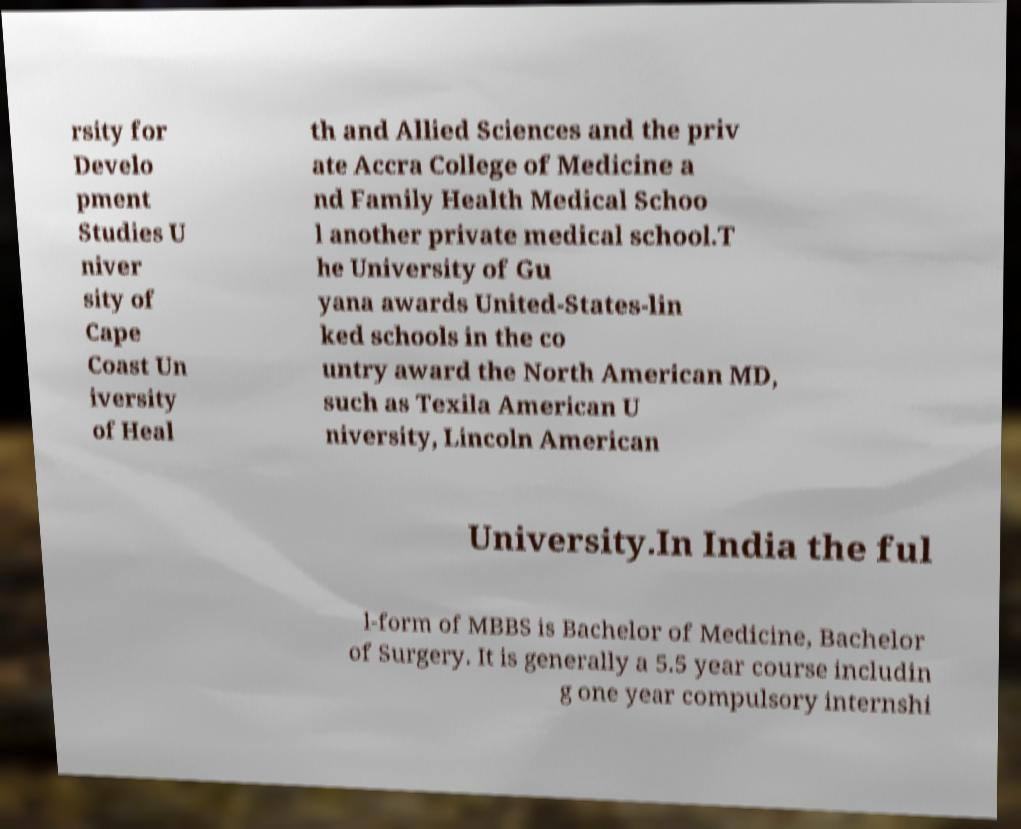There's text embedded in this image that I need extracted. Can you transcribe it verbatim? rsity for Develo pment Studies U niver sity of Cape Coast Un iversity of Heal th and Allied Sciences and the priv ate Accra College of Medicine a nd Family Health Medical Schoo l another private medical school.T he University of Gu yana awards United-States-lin ked schools in the co untry award the North American MD, such as Texila American U niversity, Lincoln American University.In India the ful l-form of MBBS is Bachelor of Medicine, Bachelor of Surgery. It is generally a 5.5 year course includin g one year compulsory internshi 